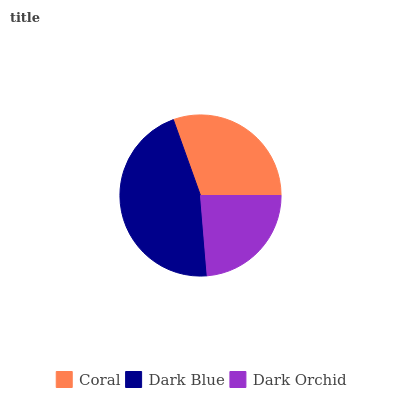Is Dark Orchid the minimum?
Answer yes or no. Yes. Is Dark Blue the maximum?
Answer yes or no. Yes. Is Dark Blue the minimum?
Answer yes or no. No. Is Dark Orchid the maximum?
Answer yes or no. No. Is Dark Blue greater than Dark Orchid?
Answer yes or no. Yes. Is Dark Orchid less than Dark Blue?
Answer yes or no. Yes. Is Dark Orchid greater than Dark Blue?
Answer yes or no. No. Is Dark Blue less than Dark Orchid?
Answer yes or no. No. Is Coral the high median?
Answer yes or no. Yes. Is Coral the low median?
Answer yes or no. Yes. Is Dark Blue the high median?
Answer yes or no. No. Is Dark Orchid the low median?
Answer yes or no. No. 